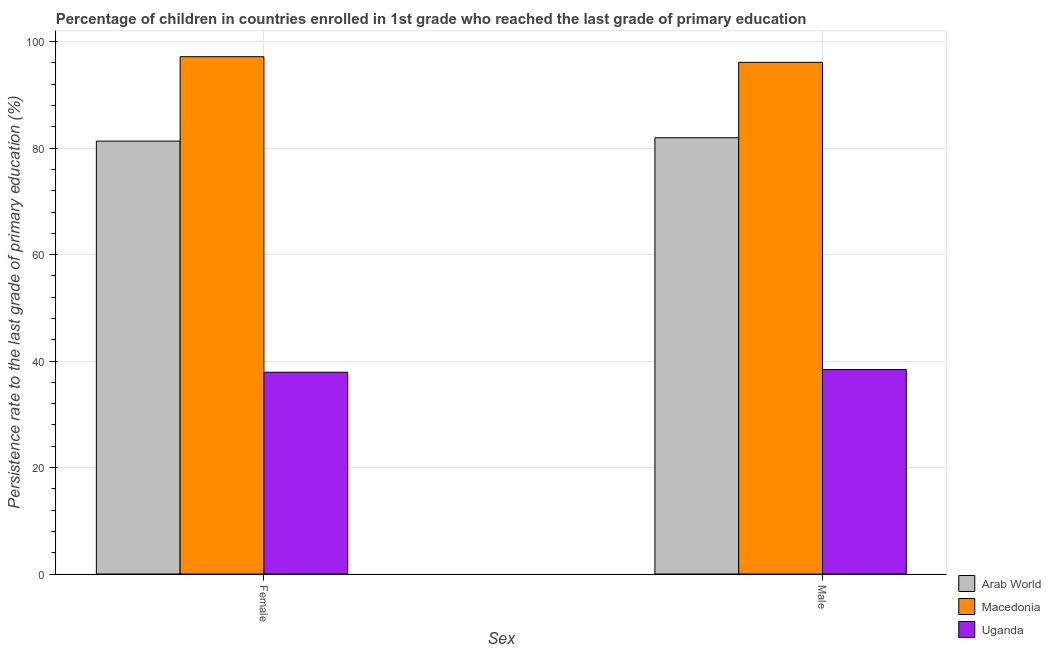Are the number of bars on each tick of the X-axis equal?
Provide a succinct answer. Yes. What is the label of the 1st group of bars from the left?
Your response must be concise. Female. What is the persistence rate of female students in Arab World?
Your response must be concise. 81.32. Across all countries, what is the maximum persistence rate of female students?
Provide a succinct answer. 97.18. Across all countries, what is the minimum persistence rate of male students?
Offer a terse response. 38.4. In which country was the persistence rate of male students maximum?
Your answer should be compact. Macedonia. In which country was the persistence rate of female students minimum?
Keep it short and to the point. Uganda. What is the total persistence rate of male students in the graph?
Keep it short and to the point. 216.46. What is the difference between the persistence rate of male students in Uganda and that in Macedonia?
Give a very brief answer. -57.71. What is the difference between the persistence rate of female students in Arab World and the persistence rate of male students in Macedonia?
Offer a terse response. -14.8. What is the average persistence rate of female students per country?
Give a very brief answer. 72.13. What is the difference between the persistence rate of female students and persistence rate of male students in Macedonia?
Your answer should be very brief. 1.06. What is the ratio of the persistence rate of male students in Macedonia to that in Uganda?
Provide a short and direct response. 2.5. In how many countries, is the persistence rate of female students greater than the average persistence rate of female students taken over all countries?
Offer a very short reply. 2. What does the 1st bar from the left in Male represents?
Provide a succinct answer. Arab World. What does the 2nd bar from the right in Female represents?
Your answer should be very brief. Macedonia. How many countries are there in the graph?
Your response must be concise. 3. Does the graph contain any zero values?
Your answer should be compact. No. Does the graph contain grids?
Make the answer very short. Yes. Where does the legend appear in the graph?
Give a very brief answer. Bottom right. What is the title of the graph?
Your answer should be very brief. Percentage of children in countries enrolled in 1st grade who reached the last grade of primary education. Does "Namibia" appear as one of the legend labels in the graph?
Provide a succinct answer. No. What is the label or title of the X-axis?
Your answer should be compact. Sex. What is the label or title of the Y-axis?
Ensure brevity in your answer.  Persistence rate to the last grade of primary education (%). What is the Persistence rate to the last grade of primary education (%) in Arab World in Female?
Offer a terse response. 81.32. What is the Persistence rate to the last grade of primary education (%) in Macedonia in Female?
Offer a very short reply. 97.18. What is the Persistence rate to the last grade of primary education (%) of Uganda in Female?
Provide a short and direct response. 37.9. What is the Persistence rate to the last grade of primary education (%) of Arab World in Male?
Give a very brief answer. 81.95. What is the Persistence rate to the last grade of primary education (%) of Macedonia in Male?
Provide a short and direct response. 96.11. What is the Persistence rate to the last grade of primary education (%) in Uganda in Male?
Ensure brevity in your answer.  38.4. Across all Sex, what is the maximum Persistence rate to the last grade of primary education (%) in Arab World?
Keep it short and to the point. 81.95. Across all Sex, what is the maximum Persistence rate to the last grade of primary education (%) of Macedonia?
Make the answer very short. 97.18. Across all Sex, what is the maximum Persistence rate to the last grade of primary education (%) of Uganda?
Your answer should be very brief. 38.4. Across all Sex, what is the minimum Persistence rate to the last grade of primary education (%) in Arab World?
Offer a very short reply. 81.32. Across all Sex, what is the minimum Persistence rate to the last grade of primary education (%) in Macedonia?
Your answer should be very brief. 96.11. Across all Sex, what is the minimum Persistence rate to the last grade of primary education (%) in Uganda?
Make the answer very short. 37.9. What is the total Persistence rate to the last grade of primary education (%) of Arab World in the graph?
Give a very brief answer. 163.26. What is the total Persistence rate to the last grade of primary education (%) in Macedonia in the graph?
Provide a short and direct response. 193.29. What is the total Persistence rate to the last grade of primary education (%) of Uganda in the graph?
Your answer should be compact. 76.3. What is the difference between the Persistence rate to the last grade of primary education (%) in Arab World in Female and that in Male?
Give a very brief answer. -0.63. What is the difference between the Persistence rate to the last grade of primary education (%) of Macedonia in Female and that in Male?
Make the answer very short. 1.06. What is the difference between the Persistence rate to the last grade of primary education (%) in Uganda in Female and that in Male?
Your answer should be compact. -0.5. What is the difference between the Persistence rate to the last grade of primary education (%) in Arab World in Female and the Persistence rate to the last grade of primary education (%) in Macedonia in Male?
Offer a very short reply. -14.8. What is the difference between the Persistence rate to the last grade of primary education (%) of Arab World in Female and the Persistence rate to the last grade of primary education (%) of Uganda in Male?
Your response must be concise. 42.92. What is the difference between the Persistence rate to the last grade of primary education (%) in Macedonia in Female and the Persistence rate to the last grade of primary education (%) in Uganda in Male?
Make the answer very short. 58.78. What is the average Persistence rate to the last grade of primary education (%) in Arab World per Sex?
Provide a short and direct response. 81.63. What is the average Persistence rate to the last grade of primary education (%) in Macedonia per Sex?
Offer a very short reply. 96.64. What is the average Persistence rate to the last grade of primary education (%) of Uganda per Sex?
Offer a terse response. 38.15. What is the difference between the Persistence rate to the last grade of primary education (%) in Arab World and Persistence rate to the last grade of primary education (%) in Macedonia in Female?
Your answer should be compact. -15.86. What is the difference between the Persistence rate to the last grade of primary education (%) of Arab World and Persistence rate to the last grade of primary education (%) of Uganda in Female?
Offer a very short reply. 43.42. What is the difference between the Persistence rate to the last grade of primary education (%) of Macedonia and Persistence rate to the last grade of primary education (%) of Uganda in Female?
Keep it short and to the point. 59.28. What is the difference between the Persistence rate to the last grade of primary education (%) in Arab World and Persistence rate to the last grade of primary education (%) in Macedonia in Male?
Offer a very short reply. -14.17. What is the difference between the Persistence rate to the last grade of primary education (%) of Arab World and Persistence rate to the last grade of primary education (%) of Uganda in Male?
Give a very brief answer. 43.55. What is the difference between the Persistence rate to the last grade of primary education (%) of Macedonia and Persistence rate to the last grade of primary education (%) of Uganda in Male?
Give a very brief answer. 57.71. What is the ratio of the Persistence rate to the last grade of primary education (%) in Macedonia in Female to that in Male?
Ensure brevity in your answer.  1.01. What is the ratio of the Persistence rate to the last grade of primary education (%) in Uganda in Female to that in Male?
Offer a very short reply. 0.99. What is the difference between the highest and the second highest Persistence rate to the last grade of primary education (%) in Arab World?
Ensure brevity in your answer.  0.63. What is the difference between the highest and the second highest Persistence rate to the last grade of primary education (%) of Macedonia?
Your answer should be very brief. 1.06. What is the difference between the highest and the second highest Persistence rate to the last grade of primary education (%) in Uganda?
Offer a very short reply. 0.5. What is the difference between the highest and the lowest Persistence rate to the last grade of primary education (%) in Arab World?
Provide a succinct answer. 0.63. What is the difference between the highest and the lowest Persistence rate to the last grade of primary education (%) in Macedonia?
Your answer should be compact. 1.06. What is the difference between the highest and the lowest Persistence rate to the last grade of primary education (%) of Uganda?
Provide a short and direct response. 0.5. 